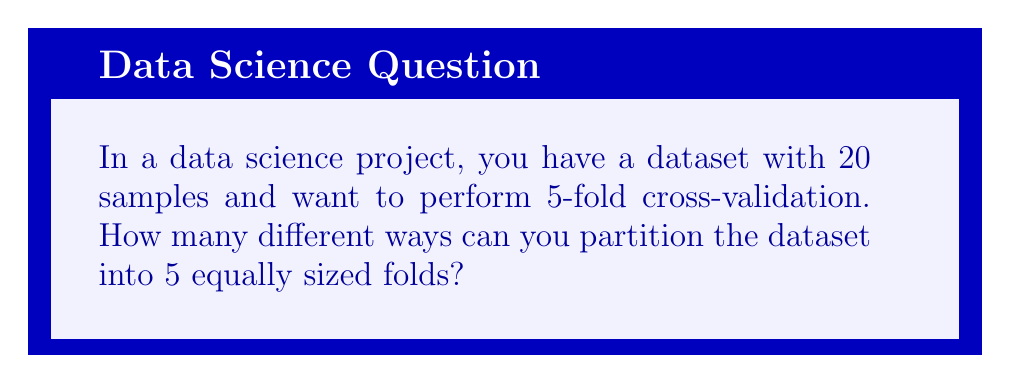Can you solve this math problem? Let's approach this step-by-step:

1) First, we need to understand what 5-fold cross-validation means. It involves dividing the dataset into 5 equal parts, where each part will be used as a test set once while the other 4 parts serve as the training set.

2) With 20 samples and 5 folds, each fold will contain 4 samples.

3) This problem is equivalent to dividing 20 distinct objects into 5 groups of 4 each. In combinatorics, this is known as a partition of a set.

4) The number of ways to partition a set of $n$ distinct objects into $k$ groups of sizes $n_1, n_2, ..., n_k$ is given by the multinomial coefficient:

   $${n \choose n_1, n_2, ..., n_k} = \frac{n!}{n_1! \cdot n_2! \cdot ... \cdot n_k!}$$

5) In our case, $n = 20$, $k = 5$, and $n_1 = n_2 = n_3 = n_4 = n_5 = 4$

6) Substituting these values:

   $${20 \choose 4, 4, 4, 4, 4} = \frac{20!}{4! \cdot 4! \cdot 4! \cdot 4! \cdot 4!}$$

7) Calculating this:
   $$\frac{20!}{(4!)^5} = \frac{20!}{(24)^5} = 11,732,745,024$$

Therefore, there are 11,732,745,024 different ways to partition the dataset for 5-fold cross-validation.
Answer: 11,732,745,024 